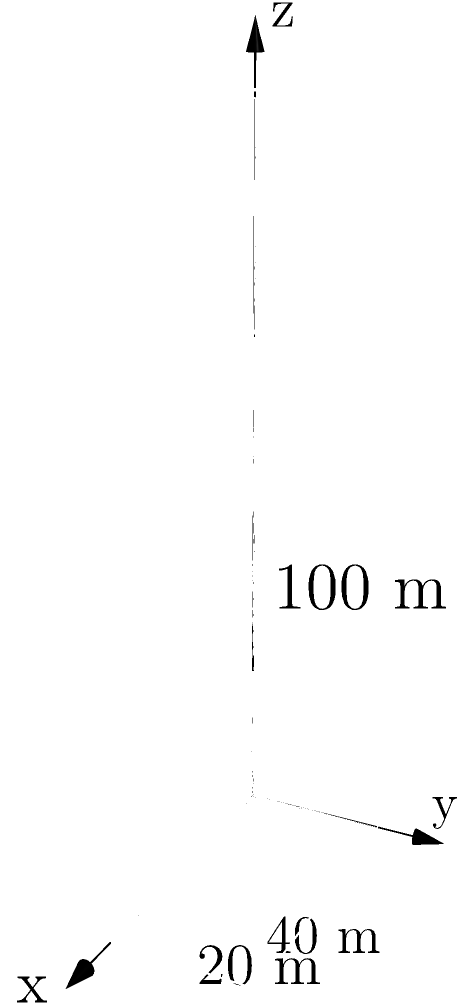Imagine you're standing in front of the Obama Tower, a sleek skyscraper in downtown Chicago. The building's shape resembles a rectangular prism with dimensions of 40 meters in length, 20 meters in width, and 100 meters in height. If you were tasked with calculating the volume of this impressive structure, what would be the result in cubic meters? Let's approach this step-by-step, using the formula for the volume of a rectangular prism:

1) The formula for the volume of a rectangular prism is:
   $V = l \times w \times h$
   where $V$ is volume, $l$ is length, $w$ is width, and $h$ is height.

2) We're given the following dimensions:
   Length $(l) = 40$ meters
   Width $(w) = 20$ meters
   Height $(h) = 100$ meters

3) Let's substitute these values into our formula:
   $V = 40 \times 20 \times 100$

4) Now, let's calculate:
   $V = 40 \times 20 = 800$
   $V = 800 \times 100 = 80,000$

5) Therefore, the volume of the Obama Tower is 80,000 cubic meters.

This volume represents the space occupied by this impressive skyscraper, showcasing the grandeur of urban architecture that President Obama, as a symbol of progress, might appreciate.
Answer: 80,000 $\text{m}^3$ 